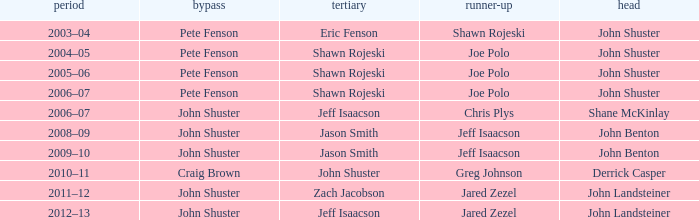Who was the lead with John Shuster as skip, Chris Plys in second, and Jeff Isaacson in third? Shane McKinlay. 